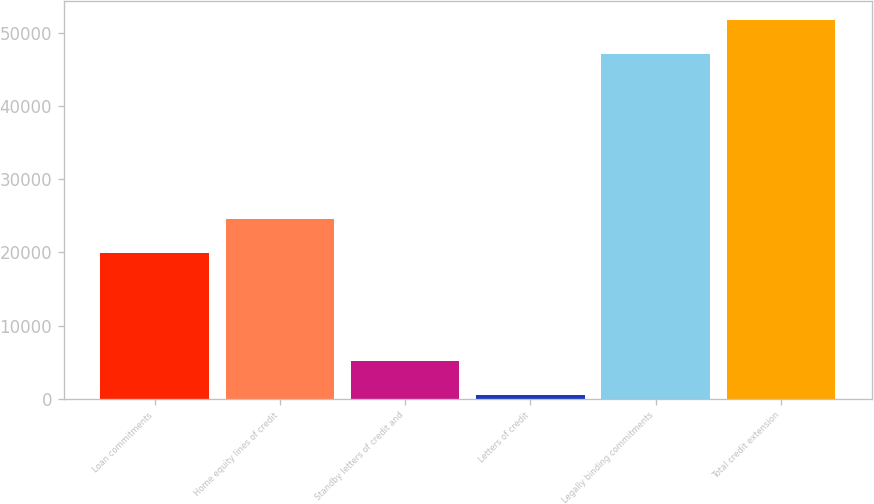<chart> <loc_0><loc_0><loc_500><loc_500><bar_chart><fcel>Loan commitments<fcel>Home equity lines of credit<fcel>Standby letters of credit and<fcel>Letters of credit<fcel>Legally binding commitments<fcel>Total credit extension<nl><fcel>19942<fcel>24596.9<fcel>5200.9<fcel>546<fcel>47095<fcel>51749.9<nl></chart> 